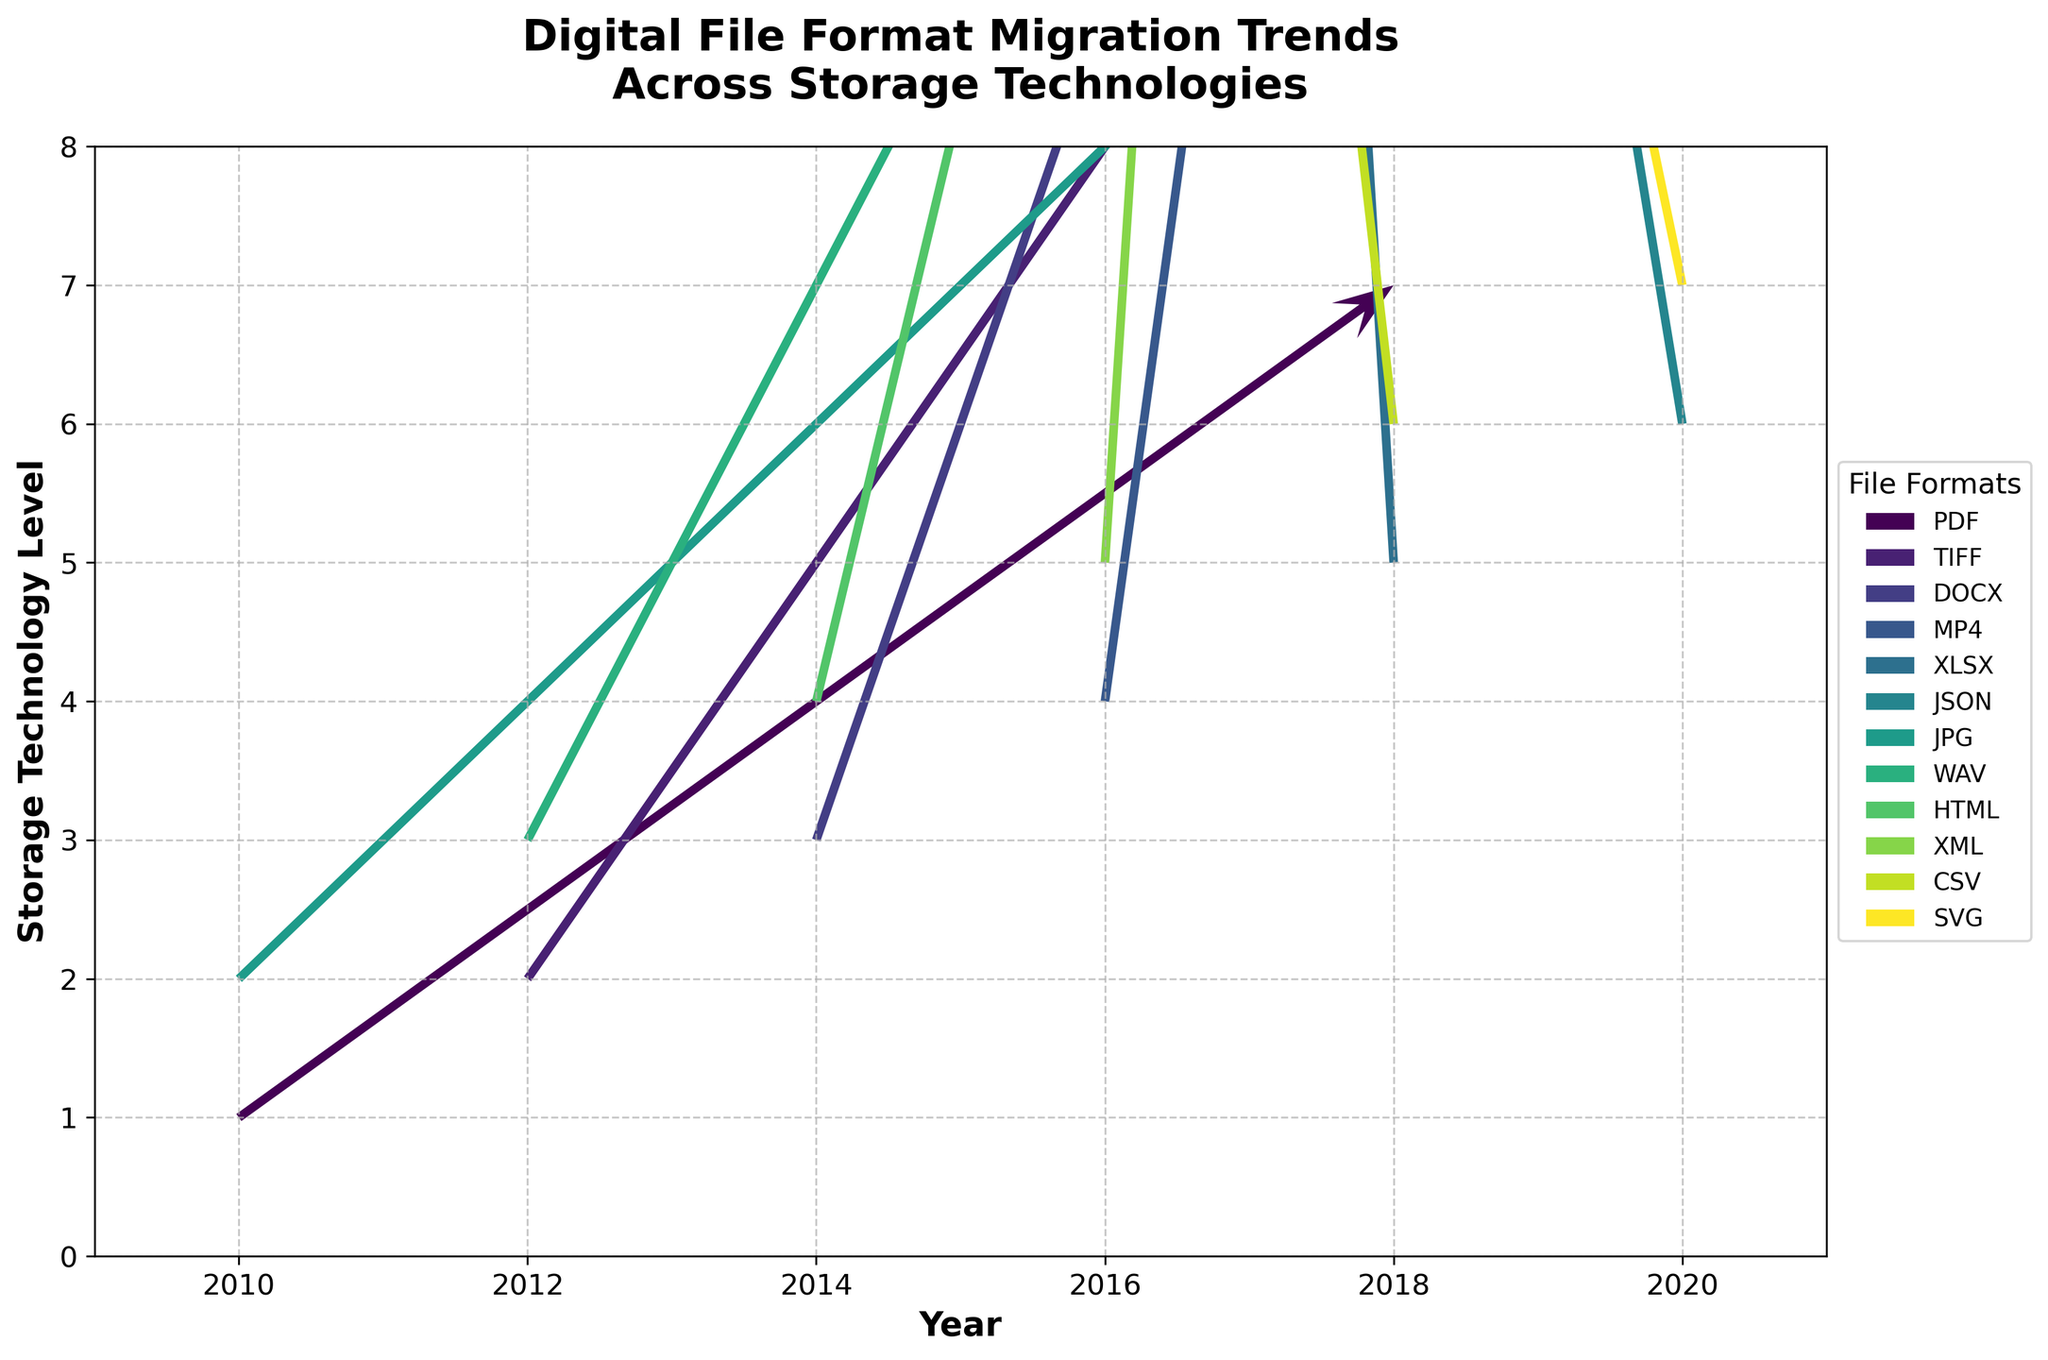what is the title of the plot? The title of the plot should provide an overview of what the data visualization is about. In this case, you can refer to the top of the plot to find the exact wording used.
Answer: Digital File Format Migration Trends Across Storage Technologies what are the axes labels? The axes labels help to indicate what each axis represents. For this plot, you can check the labels present along the x-axis and y-axis.
Answer: Year (x-axis) and Storage Technology Level (y-axis) which digital file format shows a migration direction moving downwards over the duration? To find this, look for any vector that has a downward direction in the quiver plot. Specifically, see if the 'v' component is positive but 'u' component is negative in the vectors.
Answer: XLSX between 2012 and 2014, which file format has the highest storage technology migration value? You need to look at the Y-axis values for the years 2012 and 2014 and identify which file format vector has the highest vertical component at those points.
Answer: DOCX compare the horizontal migration trends of PDF and MP4 from 2010 to 2016. Which shows a greater overall shift in storage technology level? Compare the combined horizontal 'u' controls from the quiver arrows representing PDF (2010) and MP4 (2016). PDF has a 0.8 shift, while MP4 has a 0.2.
Answer: PDF what’s the general trend in storage technology levels for JPEG, and how does it compare to SVG? Check the vectors for JPEG (from 2010, 2) and SVG (from 2020, 7). Calculate their vertical shifts (`v`).
Answer: JPEG shows a 0.7 upward trend, while SVG shows a 2.0 upward trend which year has the highest number of different FILE formats depicted? By counting the distinct file formats in each year on the x-axis, you can identify the year with the most varieties.
Answer: 2020 what is the color used to represent the MP4 file format? Each format is represented by a unique color. Identify the color of the vector representing MP4 (2016, 4, 0.2, 1.5).
Answer: Varies due to colormap; refer specifically to the plot which file format vector has the longest length and how is its length calculated in 2014? The length of a vector in a quiver plot can be found using Pythagoras' theorem, √(u^2 + v^2) for the vector. Inspect the u and v values of vectors for 2014 to determine which is longest.
Answer: DOCX; calculated as √(0.4^2 + 1.2^2) ~ 1.26 describe the overall direction seen in the migration trends from 2010 to 2020. Look at the general directions of the vectors over the time period from the start to end years and summarize the observable trends.
Answer: Upward shift in storage technology 